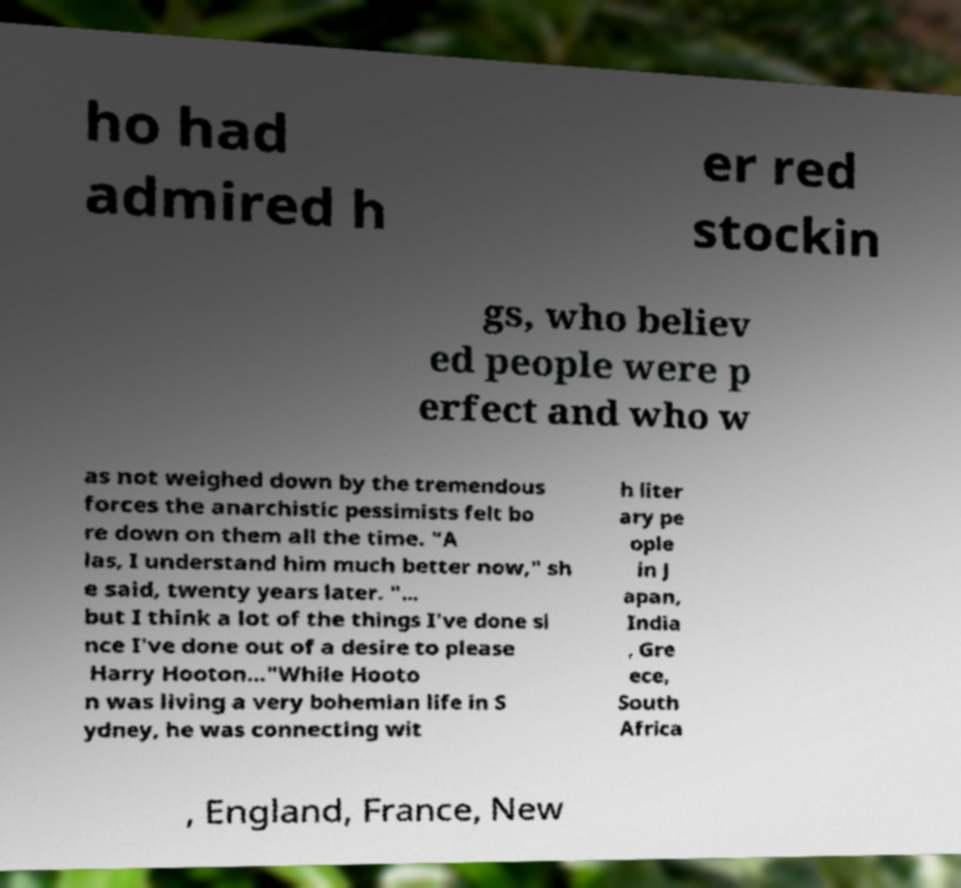For documentation purposes, I need the text within this image transcribed. Could you provide that? ho had admired h er red stockin gs, who believ ed people were p erfect and who w as not weighed down by the tremendous forces the anarchistic pessimists felt bo re down on them all the time. "A las, I understand him much better now," sh e said, twenty years later. "... but I think a lot of the things I've done si nce I've done out of a desire to please Harry Hooton..."While Hooto n was living a very bohemian life in S ydney, he was connecting wit h liter ary pe ople in J apan, India , Gre ece, South Africa , England, France, New 